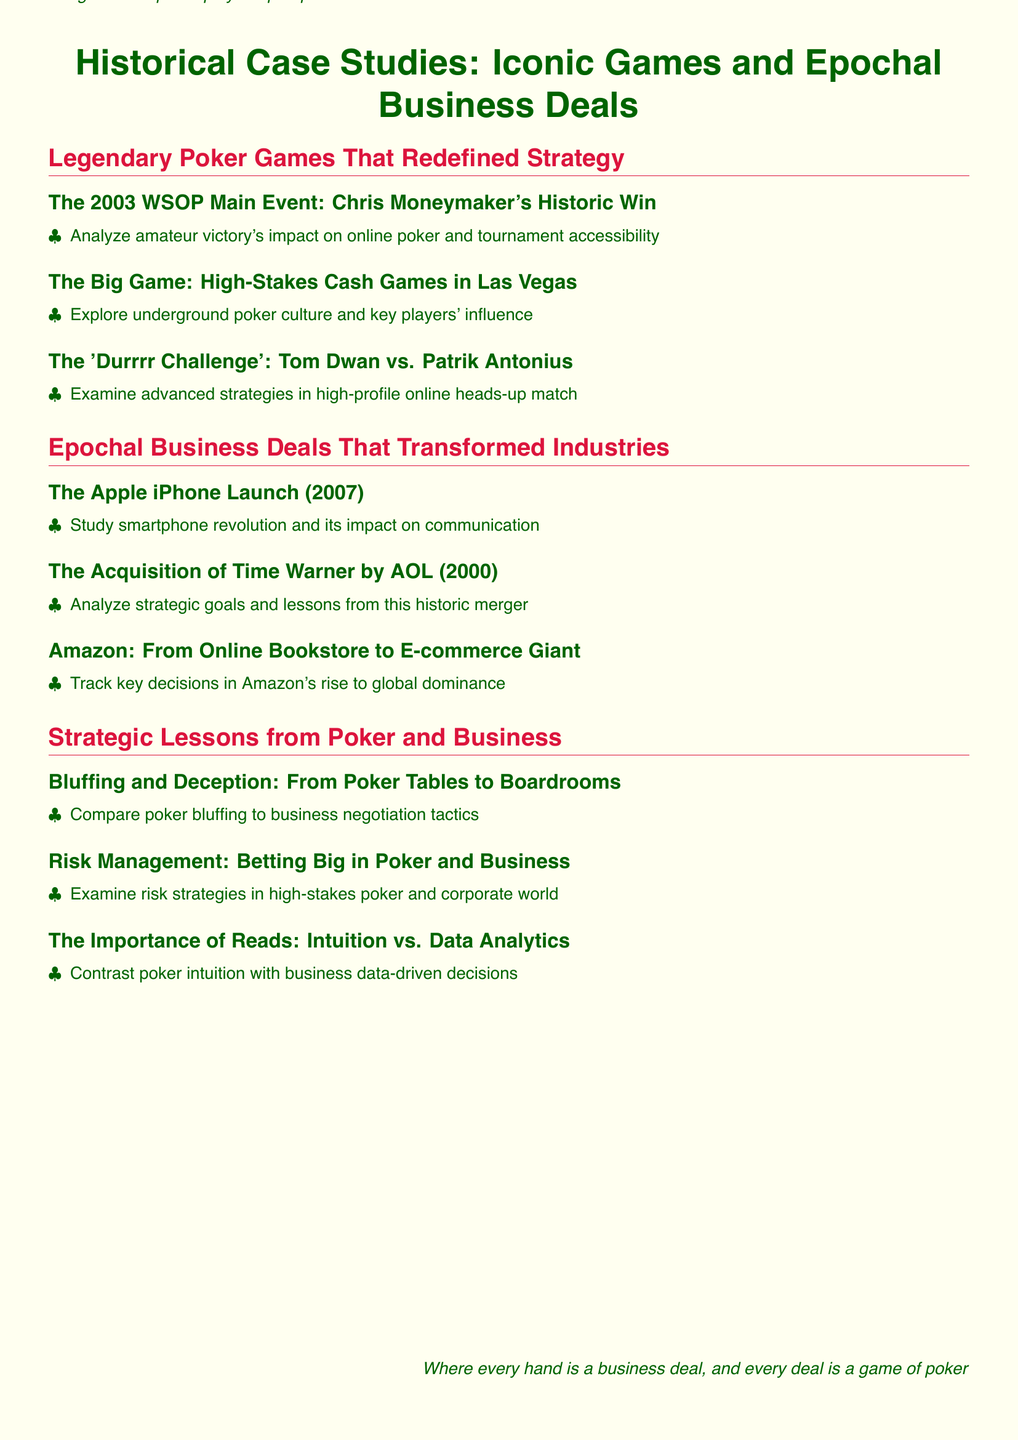What is the title of the syllabus? The title of the syllabus is presented at the beginning of the document.
Answer: Historical Case Studies: Iconic Games and Epochal Business Deals Who won the 2003 WSOP Main Event? The document mentions a specific player's victory in the context of a historic poker event.
Answer: Chris Moneymaker Which business deal is associated with the year 2000? The document highlights a particular acquisition that occurred in that year.
Answer: Acquisition of Time Warner by AOL What game is described in the 'Durrrr Challenge'? This question focuses on the specific match mentioned in the poker section of the syllabus.
Answer: Tom Dwan vs. Patrik Antonius What is one strategic lesson compared between poker and business? The document lists specific tactical comparisons between both areas.
Answer: Bluffing and Deception How did the iPhone impact communication? This information is mentioned in connection with a key event in the business section of the syllabus.
Answer: Smartphone revolution What year did the Apple iPhone launch? The launch year is specified in the document for a major event.
Answer: 2007 What is the significance of reads in poker and business? The document discusses the importance of a specific skill in both contexts.
Answer: Intuition vs. Data Analytics 